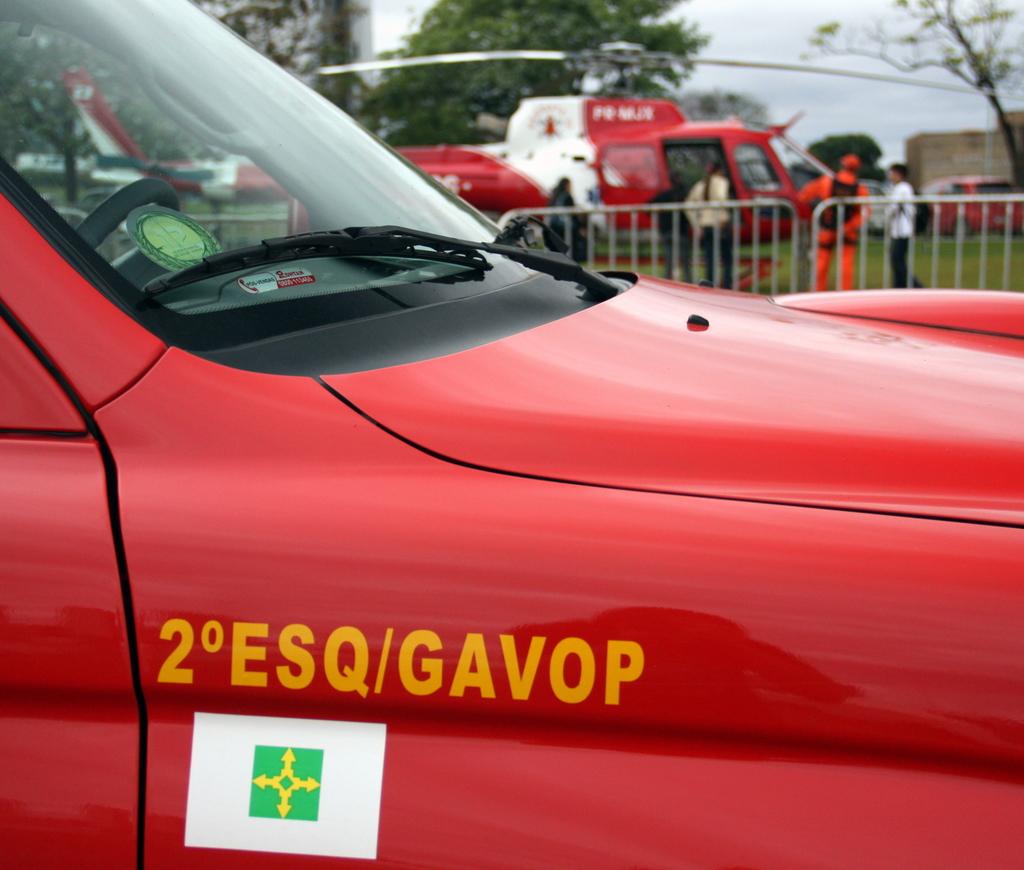What is the car number?
Your answer should be very brief. 2 esq/gavop. 